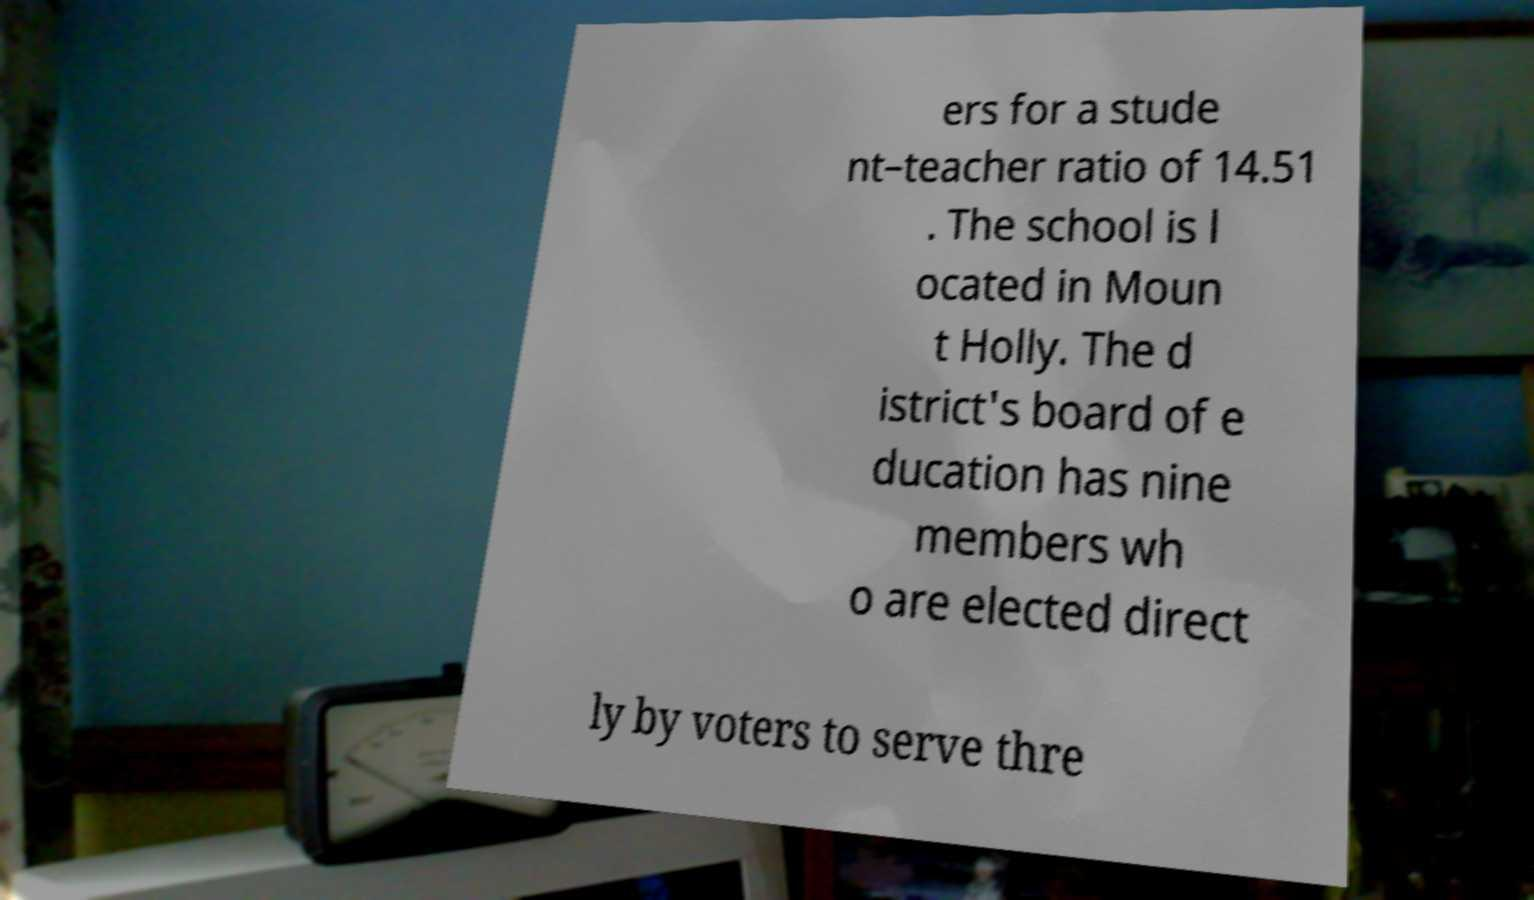Could you extract and type out the text from this image? ers for a stude nt–teacher ratio of 14.51 . The school is l ocated in Moun t Holly. The d istrict's board of e ducation has nine members wh o are elected direct ly by voters to serve thre 